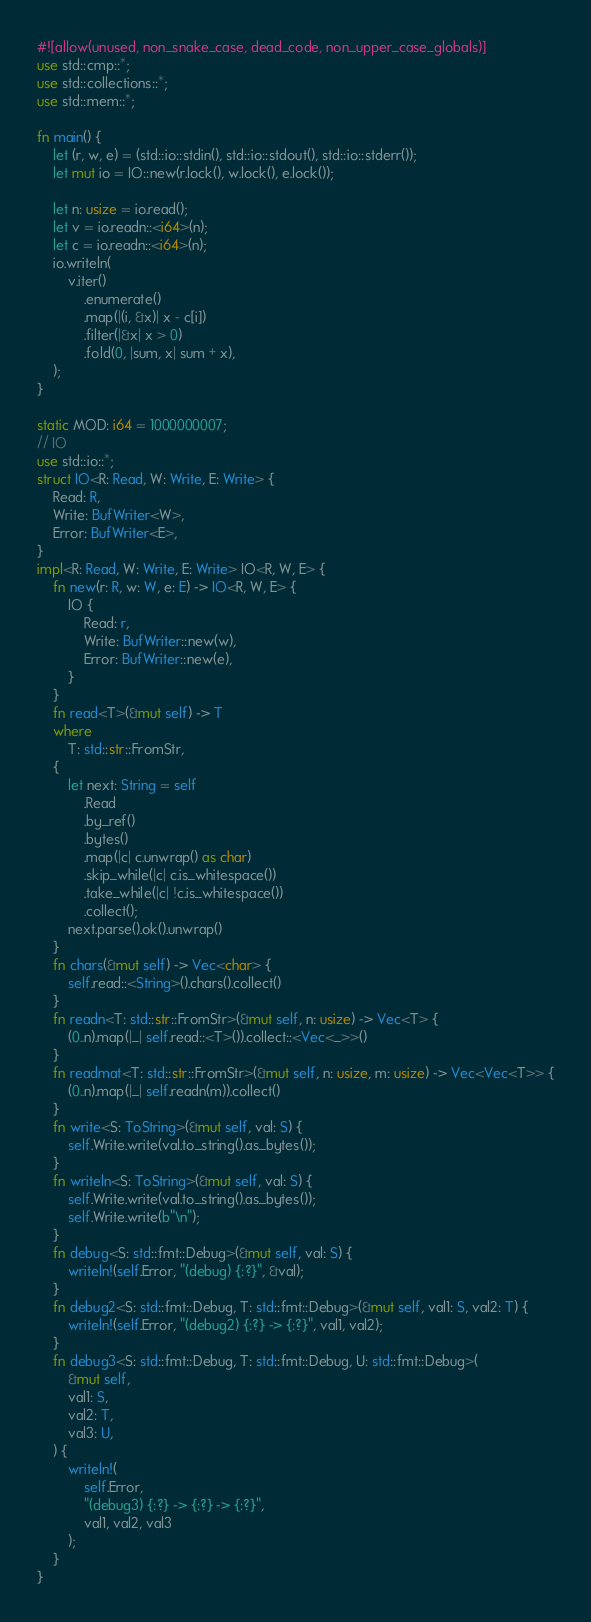Convert code to text. <code><loc_0><loc_0><loc_500><loc_500><_Rust_>#![allow(unused, non_snake_case, dead_code, non_upper_case_globals)]
use std::cmp::*;
use std::collections::*;
use std::mem::*;

fn main() {
    let (r, w, e) = (std::io::stdin(), std::io::stdout(), std::io::stderr());
    let mut io = IO::new(r.lock(), w.lock(), e.lock());

    let n: usize = io.read();
    let v = io.readn::<i64>(n);
    let c = io.readn::<i64>(n);
    io.writeln(
        v.iter()
            .enumerate()
            .map(|(i, &x)| x - c[i])
            .filter(|&x| x > 0)
            .fold(0, |sum, x| sum + x),
    );
}

static MOD: i64 = 1000000007;
// IO
use std::io::*;
struct IO<R: Read, W: Write, E: Write> {
    Read: R,
    Write: BufWriter<W>,
    Error: BufWriter<E>,
}
impl<R: Read, W: Write, E: Write> IO<R, W, E> {
    fn new(r: R, w: W, e: E) -> IO<R, W, E> {
        IO {
            Read: r,
            Write: BufWriter::new(w),
            Error: BufWriter::new(e),
        }
    }
    fn read<T>(&mut self) -> T
    where
        T: std::str::FromStr,
    {
        let next: String = self
            .Read
            .by_ref()
            .bytes()
            .map(|c| c.unwrap() as char)
            .skip_while(|c| c.is_whitespace())
            .take_while(|c| !c.is_whitespace())
            .collect();
        next.parse().ok().unwrap()
    }
    fn chars(&mut self) -> Vec<char> {
        self.read::<String>().chars().collect()
    }
    fn readn<T: std::str::FromStr>(&mut self, n: usize) -> Vec<T> {
        (0..n).map(|_| self.read::<T>()).collect::<Vec<_>>()
    }
    fn readmat<T: std::str::FromStr>(&mut self, n: usize, m: usize) -> Vec<Vec<T>> {
        (0..n).map(|_| self.readn(m)).collect()
    }
    fn write<S: ToString>(&mut self, val: S) {
        self.Write.write(val.to_string().as_bytes());
    }
    fn writeln<S: ToString>(&mut self, val: S) {
        self.Write.write(val.to_string().as_bytes());
        self.Write.write(b"\n");
    }
    fn debug<S: std::fmt::Debug>(&mut self, val: S) {
        writeln!(self.Error, "(debug) {:?}", &val);
    }
    fn debug2<S: std::fmt::Debug, T: std::fmt::Debug>(&mut self, val1: S, val2: T) {
        writeln!(self.Error, "(debug2) {:?} -> {:?}", val1, val2);
    }
    fn debug3<S: std::fmt::Debug, T: std::fmt::Debug, U: std::fmt::Debug>(
        &mut self,
        val1: S,
        val2: T,
        val3: U,
    ) {
        writeln!(
            self.Error,
            "(debug3) {:?} -> {:?} -> {:?}",
            val1, val2, val3
        );
    }
}
</code> 